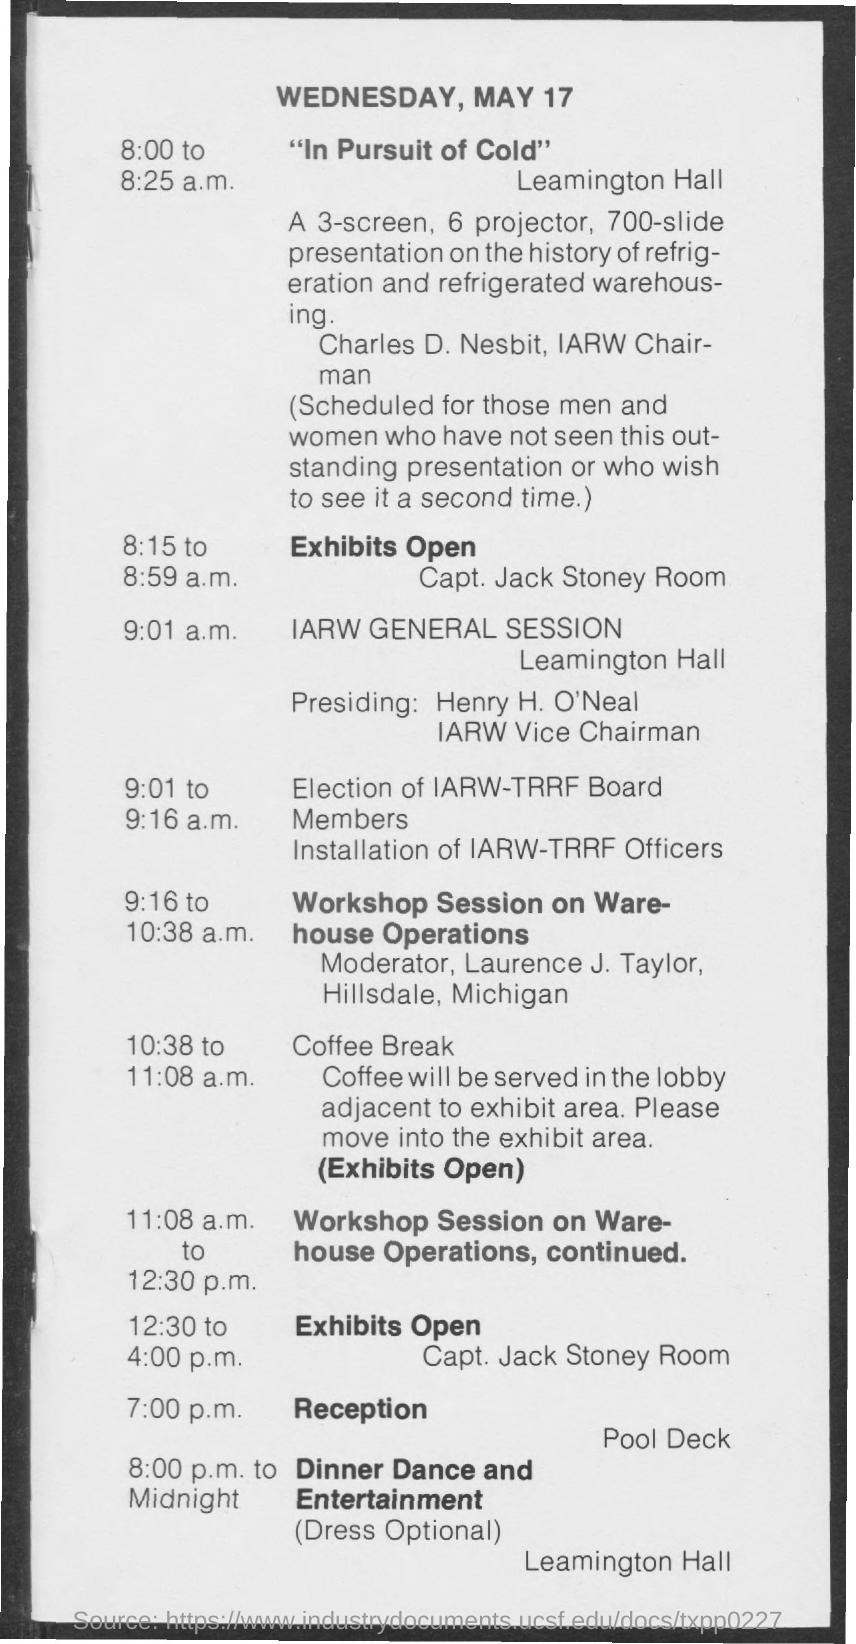Outline some significant characteristics in this image. The date mentioned on the given page is Wednesday, May 17. 